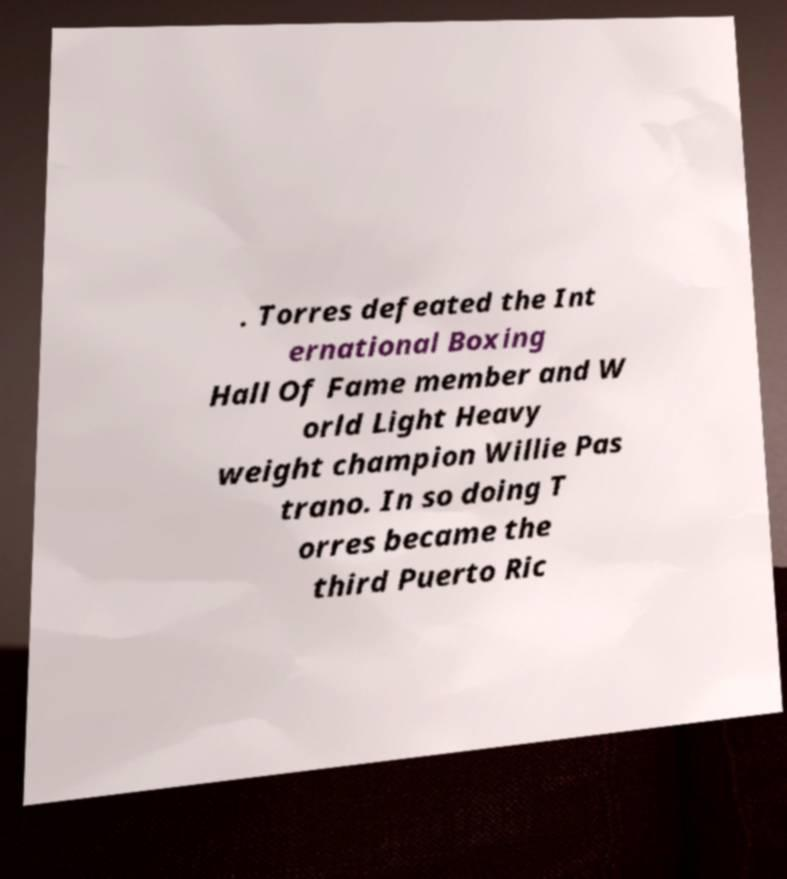There's text embedded in this image that I need extracted. Can you transcribe it verbatim? . Torres defeated the Int ernational Boxing Hall Of Fame member and W orld Light Heavy weight champion Willie Pas trano. In so doing T orres became the third Puerto Ric 